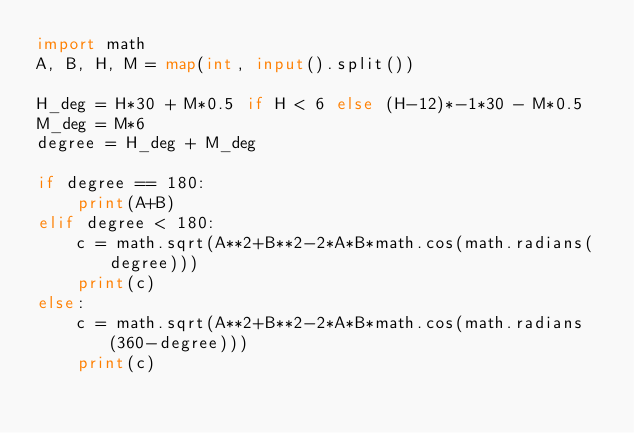Convert code to text. <code><loc_0><loc_0><loc_500><loc_500><_Python_>import math
A, B, H, M = map(int, input().split())

H_deg = H*30 + M*0.5 if H < 6 else (H-12)*-1*30 - M*0.5
M_deg = M*6
degree = H_deg + M_deg

if degree == 180:
    print(A+B)
elif degree < 180:
    c = math.sqrt(A**2+B**2-2*A*B*math.cos(math.radians(degree)))
    print(c)
else:
    c = math.sqrt(A**2+B**2-2*A*B*math.cos(math.radians(360-degree)))
    print(c)</code> 